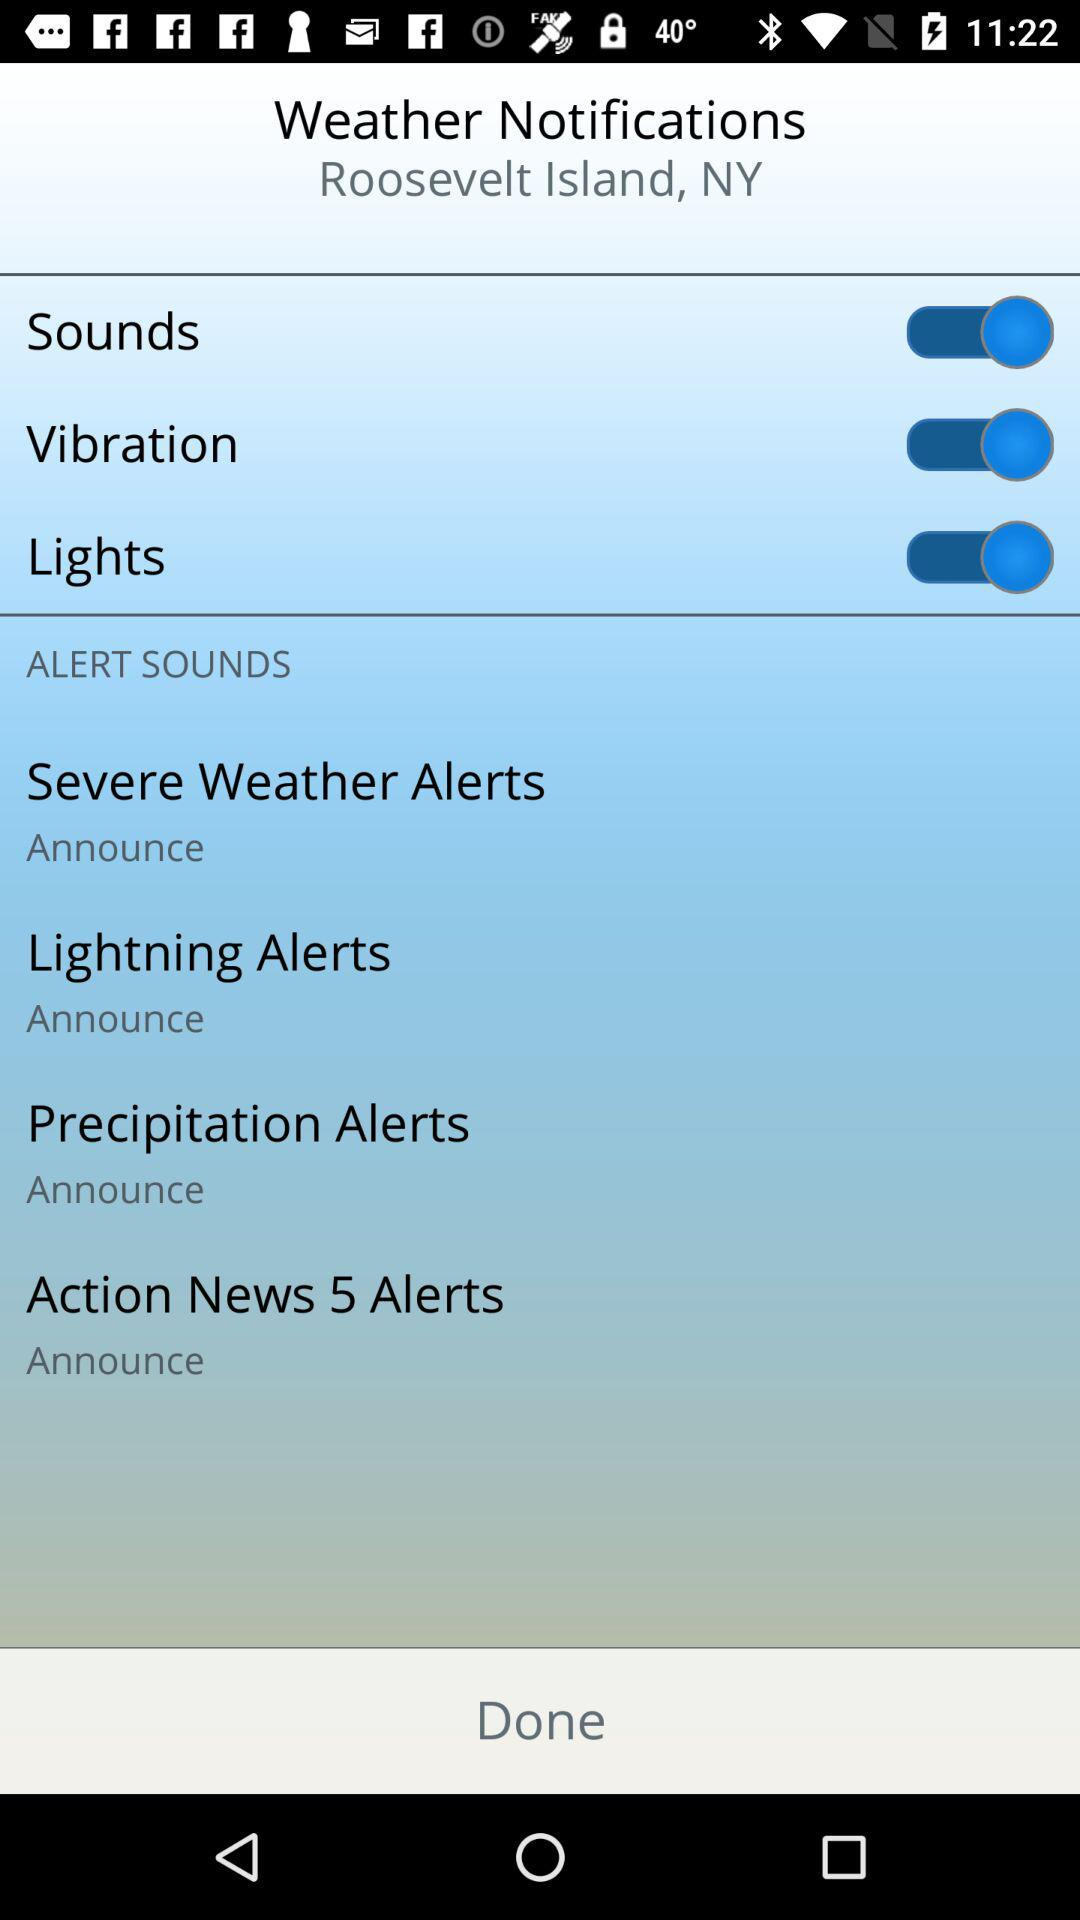What is the current status of vibration? The current status of vibration is on. 